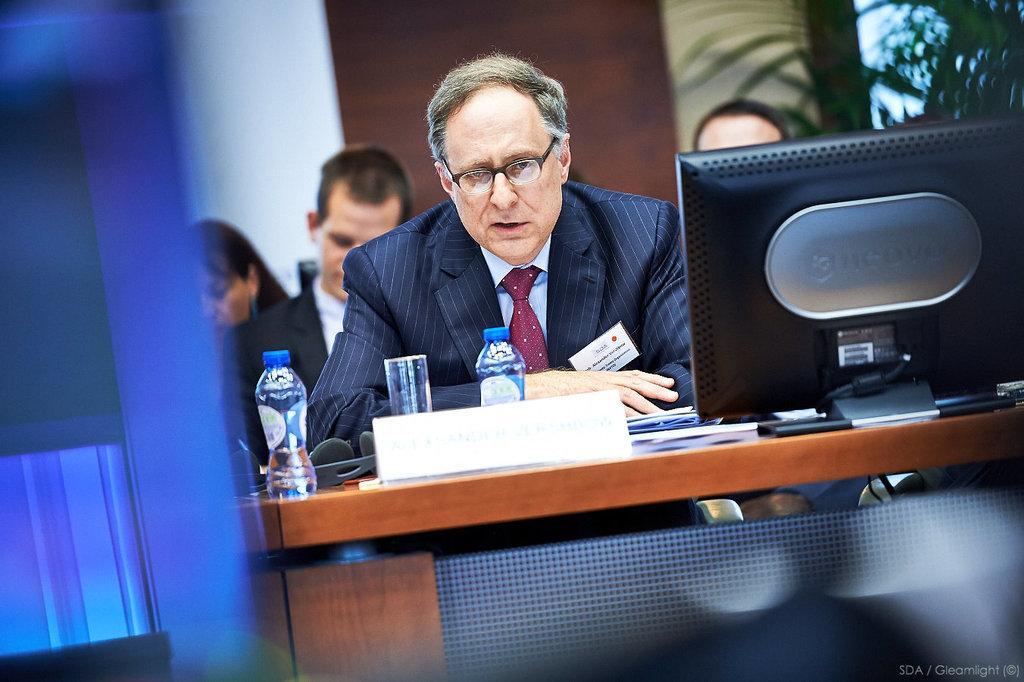Could you give a brief overview of what you see in this image? In this image we can see a man is sitting. In front of the man, we can see a table. On the table, we can see the monitor, name plate, glass, bottles and some objects. In the background, we can see two men, a woman, plant and a wall. There is a watermark in the right bottom of the image. It seems like a door on the left side of the image. 